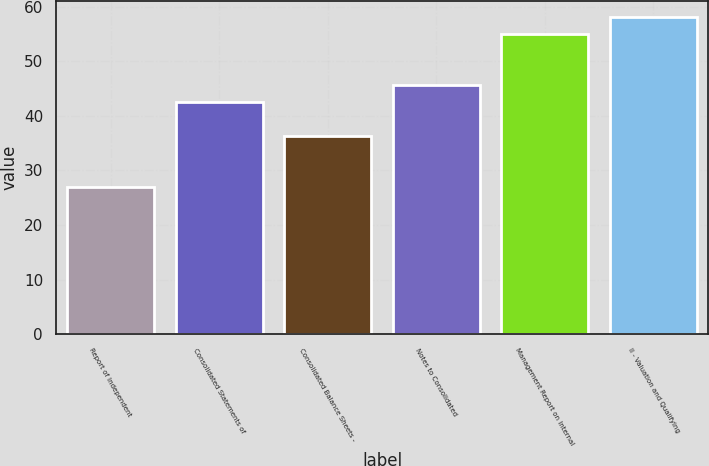Convert chart. <chart><loc_0><loc_0><loc_500><loc_500><bar_chart><fcel>Report of Independent<fcel>Consolidated Statements of<fcel>Consolidated Balance Sheets -<fcel>Notes to Consolidated<fcel>Management Report on Internal<fcel>II - Valuation and Qualifying<nl><fcel>27<fcel>42.5<fcel>36.3<fcel>45.6<fcel>55<fcel>58.1<nl></chart> 